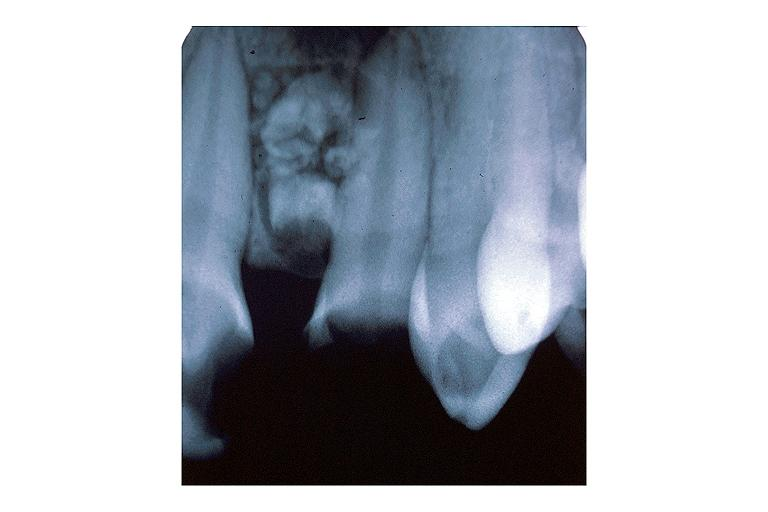where is this?
Answer the question using a single word or phrase. Oral 